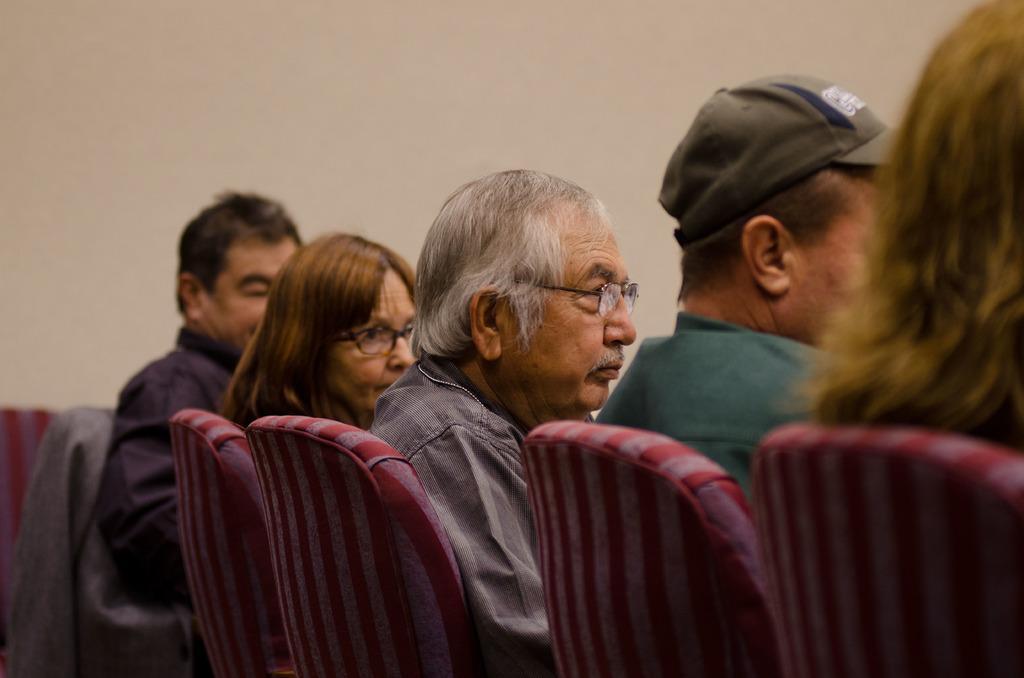Describe this image in one or two sentences. Here an old man is sitting on the chair, he wore shirt, spectacles. Beside him a woman is sitting and few other persons are sitting and this is the wall. 